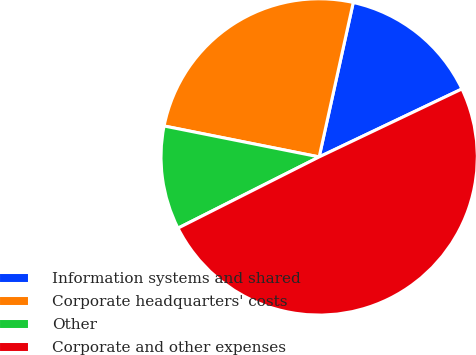<chart> <loc_0><loc_0><loc_500><loc_500><pie_chart><fcel>Information systems and shared<fcel>Corporate headquarters' costs<fcel>Other<fcel>Corporate and other expenses<nl><fcel>14.47%<fcel>25.32%<fcel>10.57%<fcel>49.63%<nl></chart> 